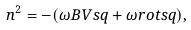<formula> <loc_0><loc_0><loc_500><loc_500>n ^ { 2 } = - ( \omega B V s q + \omega r o t s q ) ,</formula> 